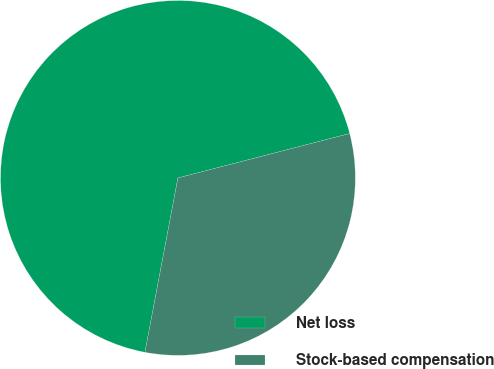Convert chart. <chart><loc_0><loc_0><loc_500><loc_500><pie_chart><fcel>Net loss<fcel>Stock-based compensation<nl><fcel>68.0%<fcel>32.0%<nl></chart> 